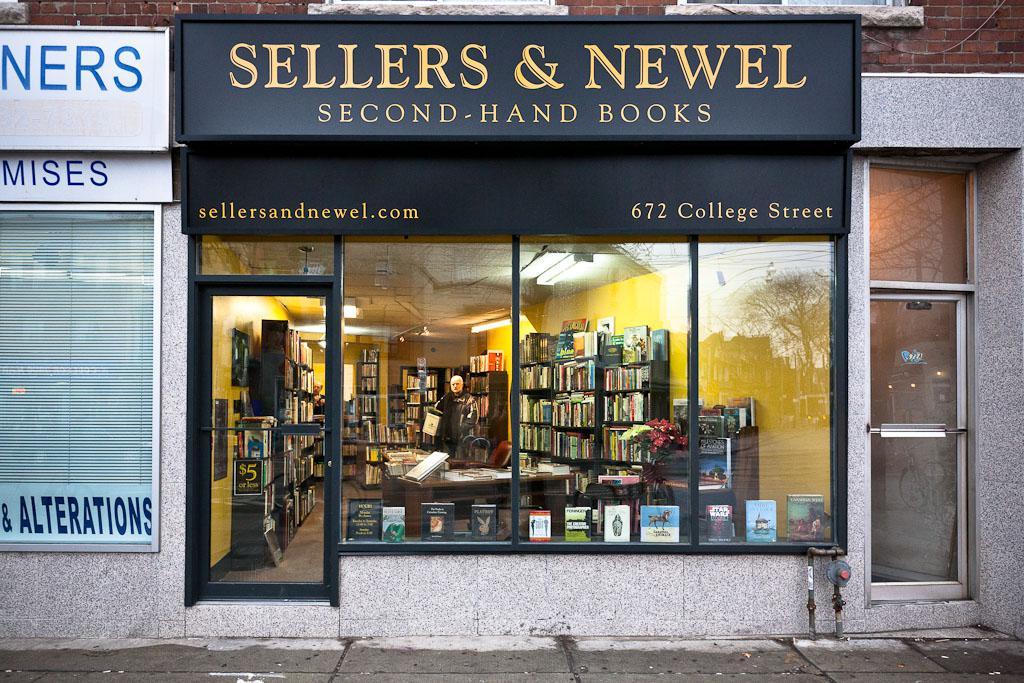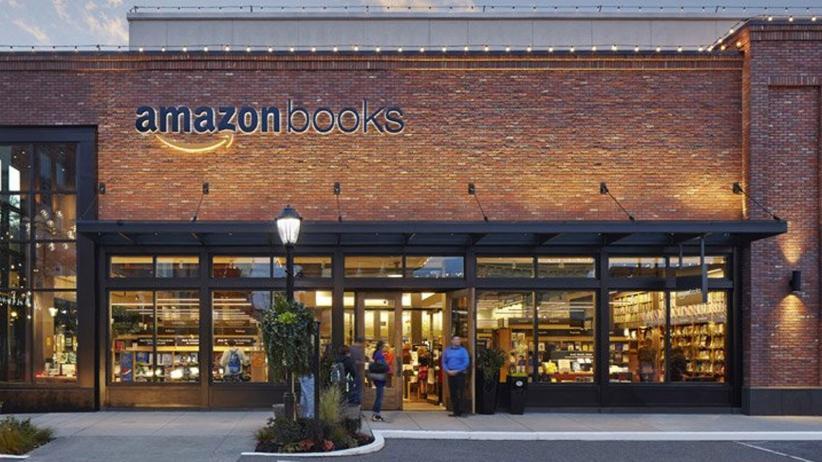The first image is the image on the left, the second image is the image on the right. Examine the images to the left and right. Is the description "The bookstores are all brightly lit up on the inside." accurate? Answer yes or no. Yes. The first image is the image on the left, the second image is the image on the right. For the images shown, is this caption "In at least one image there is a brick store with at least three window and a black awning." true? Answer yes or no. Yes. 